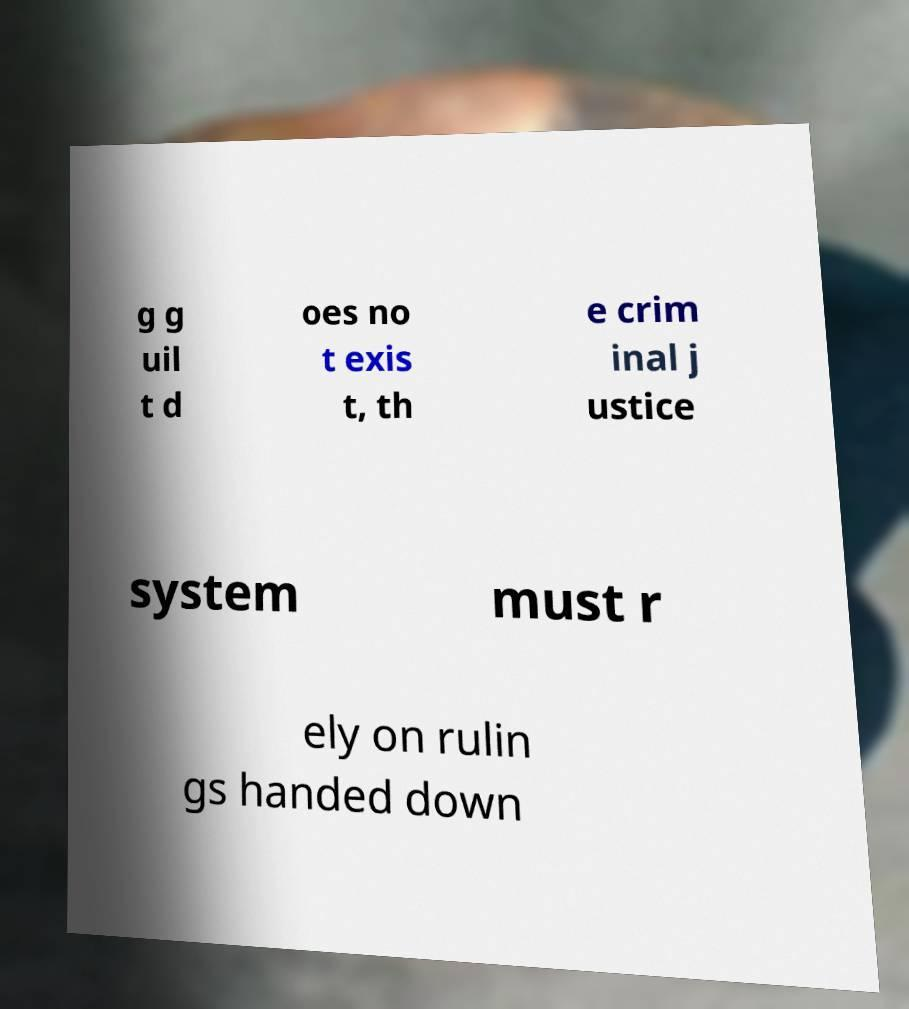Can you accurately transcribe the text from the provided image for me? g g uil t d oes no t exis t, th e crim inal j ustice system must r ely on rulin gs handed down 